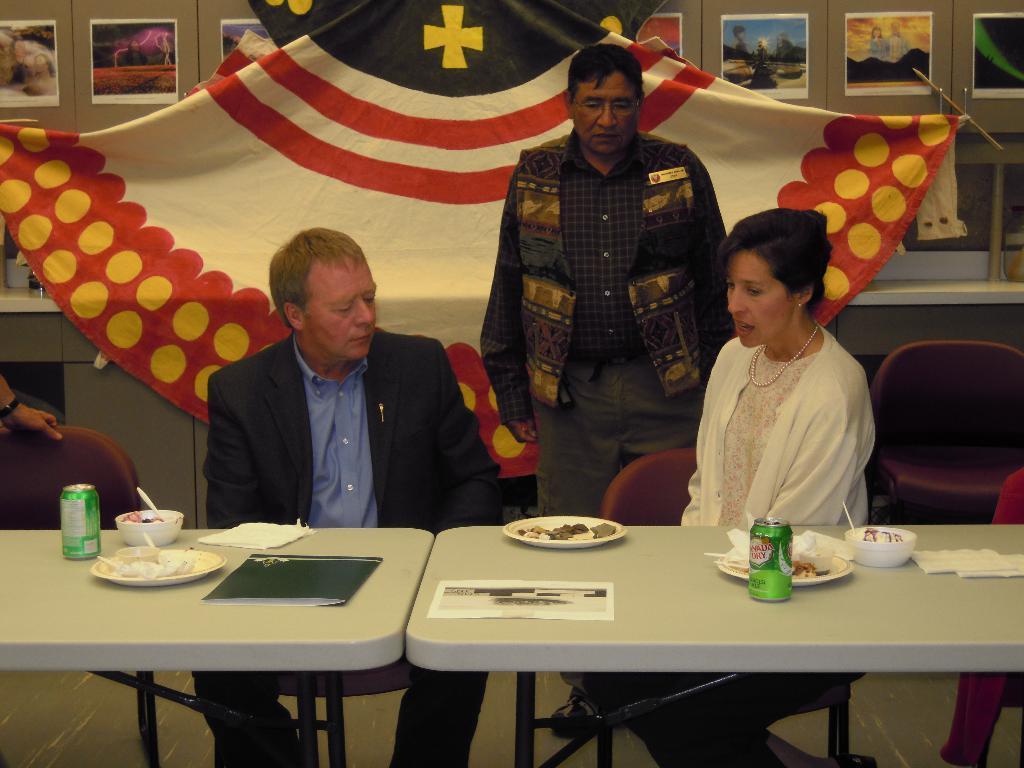Could you give a brief overview of what you see in this image? The picture might be taken in a meeting. In the foreground of the picture there are two tables, on the tables there are plates, bowls, tins and papers. In the center of the picture there are two people sitting in chairs. In the background there is a flag. On the top there is a wall and there are posters attached to the wall. In the center of the picture there is a man standing. 